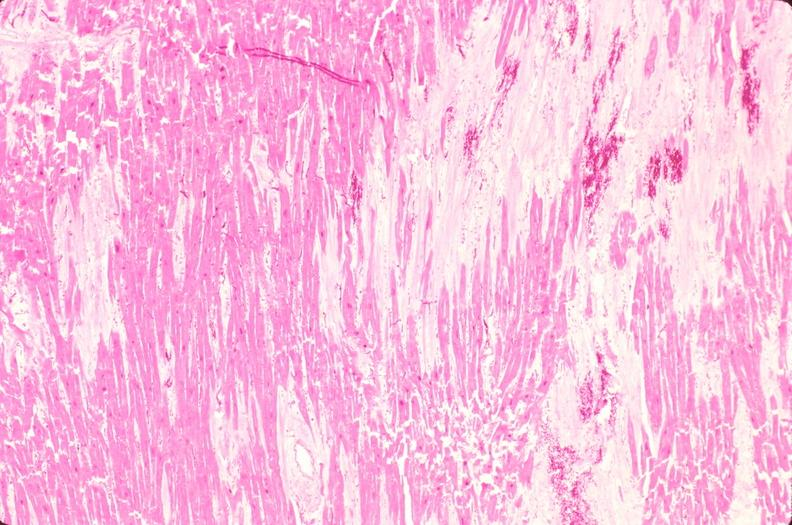s vessel present?
Answer the question using a single word or phrase. No 